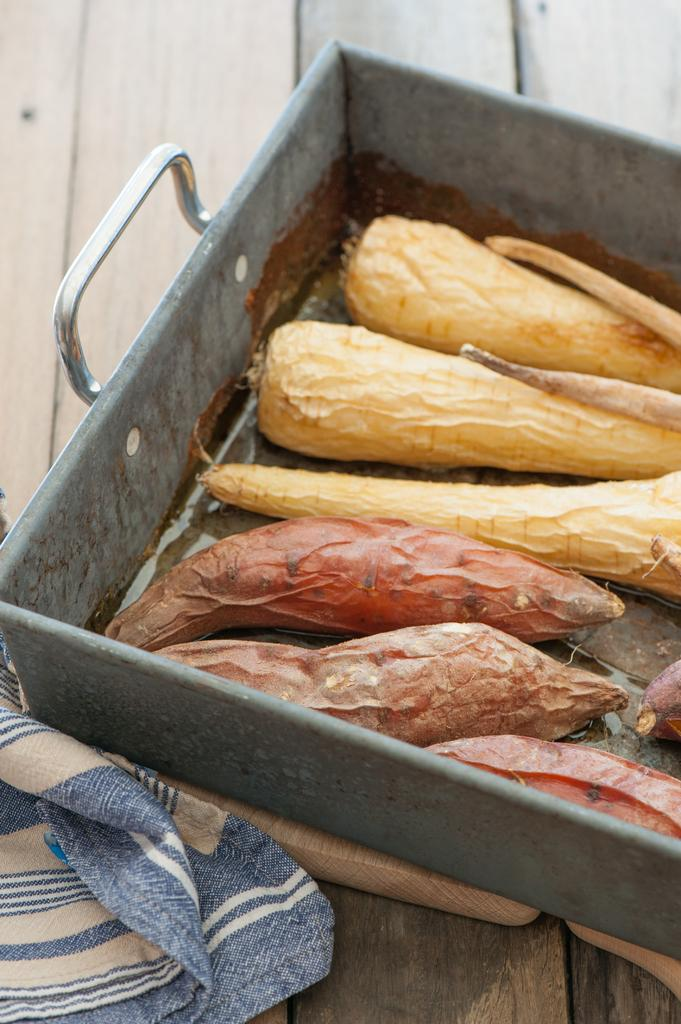What is on the wooden table in the image? There is a tray and a cloth on the wooden table in the image. What is on the tray? The tray contains vegetables. What type of wall is visible in the image? There is a wooden wall visible in the image. Where are the pigs located in the image? There are no pigs present in the image. Is the room depicted in the image a bedroom? The provided facts do not indicate the type of room shown in the image. 